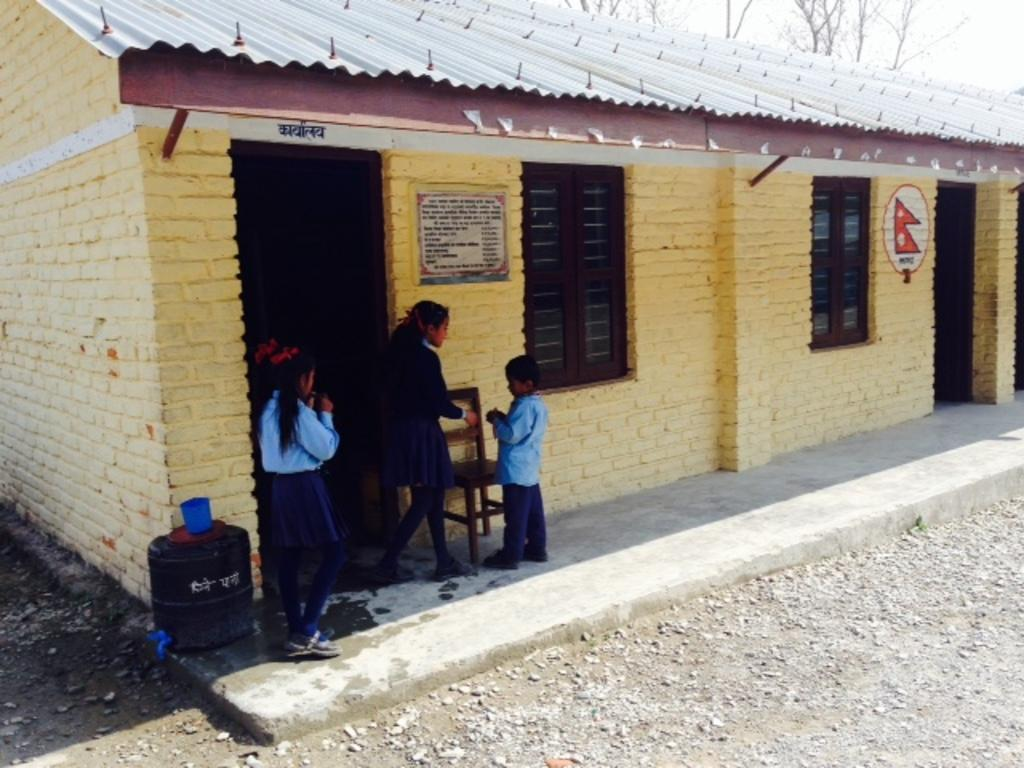What type of building is shown in the image? There is a school in the image. Where are the students located in the image? The students are on the left side of the image. What can be seen on the ground in the image? Small stones are visible on the ground. What is visible in the background of the image? There are trees and the sky in the background of the image. What title does the pest have in the image? There is no pest present in the image, so it does not have a title. 